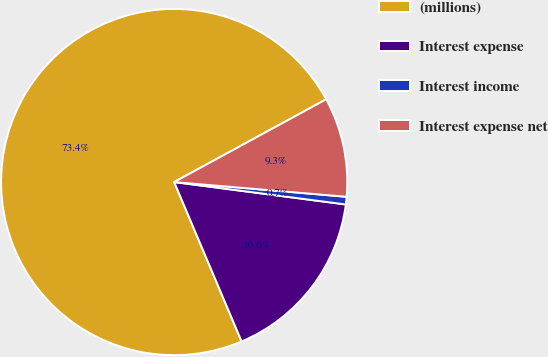Convert chart. <chart><loc_0><loc_0><loc_500><loc_500><pie_chart><fcel>(millions)<fcel>Interest expense<fcel>Interest income<fcel>Interest expense net<nl><fcel>73.44%<fcel>16.56%<fcel>0.71%<fcel>9.29%<nl></chart> 